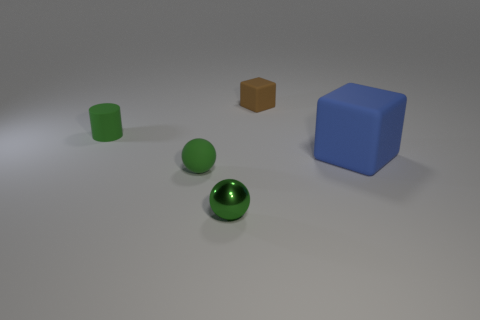Add 2 large red cylinders. How many objects exist? 7 Subtract 1 blocks. How many blocks are left? 1 Add 4 blue metal things. How many blue metal things exist? 4 Subtract 0 cyan blocks. How many objects are left? 5 Subtract all cylinders. How many objects are left? 4 Subtract all red spheres. Subtract all red cubes. How many spheres are left? 2 Subtract all red cylinders. How many gray cubes are left? 0 Subtract all cyan rubber cylinders. Subtract all cylinders. How many objects are left? 4 Add 2 tiny green cylinders. How many tiny green cylinders are left? 3 